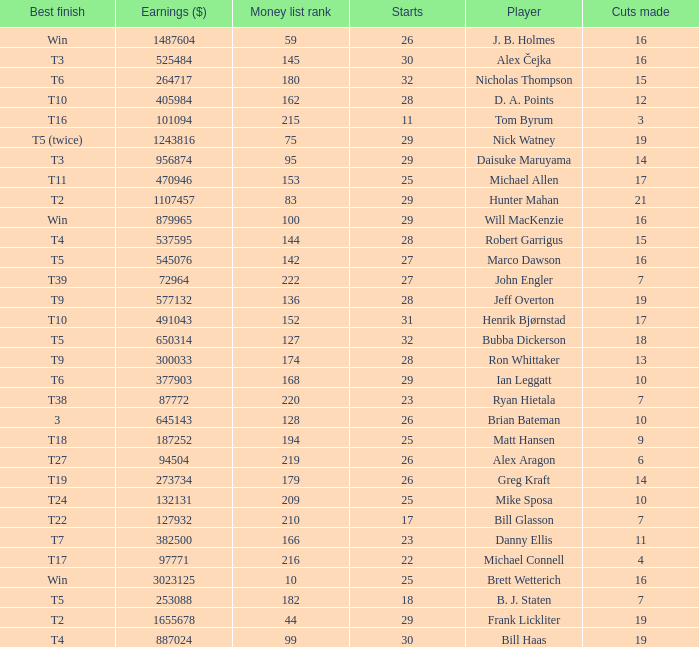What is the minimum number of cuts made for Hunter Mahan? 21.0. 